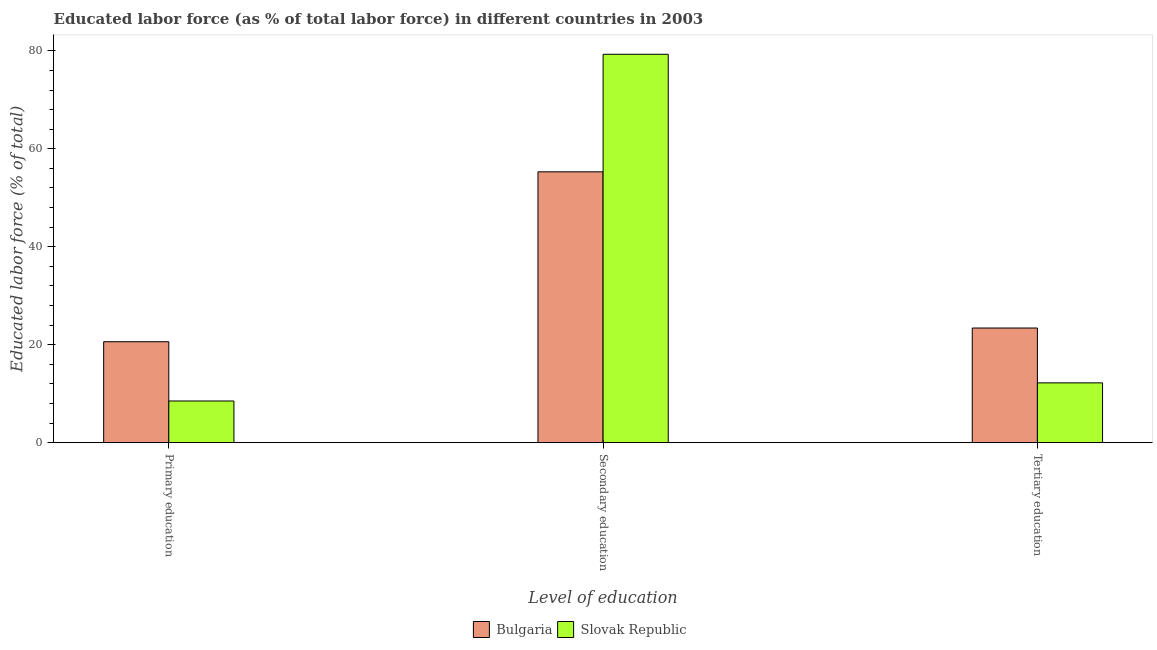How many different coloured bars are there?
Provide a short and direct response. 2. How many bars are there on the 1st tick from the right?
Ensure brevity in your answer.  2. What is the label of the 3rd group of bars from the left?
Make the answer very short. Tertiary education. What is the percentage of labor force who received tertiary education in Slovak Republic?
Provide a succinct answer. 12.2. Across all countries, what is the maximum percentage of labor force who received tertiary education?
Your response must be concise. 23.4. Across all countries, what is the minimum percentage of labor force who received tertiary education?
Keep it short and to the point. 12.2. In which country was the percentage of labor force who received secondary education maximum?
Your answer should be very brief. Slovak Republic. In which country was the percentage of labor force who received primary education minimum?
Offer a very short reply. Slovak Republic. What is the total percentage of labor force who received secondary education in the graph?
Provide a short and direct response. 134.6. What is the difference between the percentage of labor force who received tertiary education in Bulgaria and that in Slovak Republic?
Give a very brief answer. 11.2. What is the difference between the percentage of labor force who received tertiary education in Bulgaria and the percentage of labor force who received primary education in Slovak Republic?
Provide a succinct answer. 14.9. What is the average percentage of labor force who received secondary education per country?
Make the answer very short. 67.3. What is the difference between the percentage of labor force who received primary education and percentage of labor force who received tertiary education in Bulgaria?
Offer a terse response. -2.8. In how many countries, is the percentage of labor force who received primary education greater than 16 %?
Your answer should be compact. 1. What is the ratio of the percentage of labor force who received secondary education in Slovak Republic to that in Bulgaria?
Provide a short and direct response. 1.43. Is the percentage of labor force who received secondary education in Bulgaria less than that in Slovak Republic?
Your answer should be very brief. Yes. Is the difference between the percentage of labor force who received primary education in Slovak Republic and Bulgaria greater than the difference between the percentage of labor force who received tertiary education in Slovak Republic and Bulgaria?
Provide a short and direct response. No. What is the difference between the highest and the second highest percentage of labor force who received secondary education?
Your answer should be very brief. 24. What is the difference between the highest and the lowest percentage of labor force who received secondary education?
Provide a short and direct response. 24. What does the 1st bar from the left in Primary education represents?
Give a very brief answer. Bulgaria. What does the 1st bar from the right in Secondary education represents?
Give a very brief answer. Slovak Republic. How many bars are there?
Your response must be concise. 6. Are all the bars in the graph horizontal?
Give a very brief answer. No. How many countries are there in the graph?
Your response must be concise. 2. Are the values on the major ticks of Y-axis written in scientific E-notation?
Provide a short and direct response. No. Does the graph contain grids?
Your answer should be very brief. No. Where does the legend appear in the graph?
Give a very brief answer. Bottom center. How many legend labels are there?
Offer a very short reply. 2. What is the title of the graph?
Give a very brief answer. Educated labor force (as % of total labor force) in different countries in 2003. Does "Rwanda" appear as one of the legend labels in the graph?
Your answer should be very brief. No. What is the label or title of the X-axis?
Your answer should be compact. Level of education. What is the label or title of the Y-axis?
Your answer should be very brief. Educated labor force (% of total). What is the Educated labor force (% of total) in Bulgaria in Primary education?
Ensure brevity in your answer.  20.6. What is the Educated labor force (% of total) of Slovak Republic in Primary education?
Give a very brief answer. 8.5. What is the Educated labor force (% of total) in Bulgaria in Secondary education?
Provide a succinct answer. 55.3. What is the Educated labor force (% of total) of Slovak Republic in Secondary education?
Offer a terse response. 79.3. What is the Educated labor force (% of total) in Bulgaria in Tertiary education?
Keep it short and to the point. 23.4. What is the Educated labor force (% of total) in Slovak Republic in Tertiary education?
Ensure brevity in your answer.  12.2. Across all Level of education, what is the maximum Educated labor force (% of total) in Bulgaria?
Offer a terse response. 55.3. Across all Level of education, what is the maximum Educated labor force (% of total) in Slovak Republic?
Your answer should be very brief. 79.3. Across all Level of education, what is the minimum Educated labor force (% of total) of Bulgaria?
Your response must be concise. 20.6. What is the total Educated labor force (% of total) in Bulgaria in the graph?
Offer a very short reply. 99.3. What is the difference between the Educated labor force (% of total) in Bulgaria in Primary education and that in Secondary education?
Make the answer very short. -34.7. What is the difference between the Educated labor force (% of total) in Slovak Republic in Primary education and that in Secondary education?
Keep it short and to the point. -70.8. What is the difference between the Educated labor force (% of total) of Bulgaria in Primary education and that in Tertiary education?
Your response must be concise. -2.8. What is the difference between the Educated labor force (% of total) in Bulgaria in Secondary education and that in Tertiary education?
Offer a very short reply. 31.9. What is the difference between the Educated labor force (% of total) of Slovak Republic in Secondary education and that in Tertiary education?
Provide a succinct answer. 67.1. What is the difference between the Educated labor force (% of total) of Bulgaria in Primary education and the Educated labor force (% of total) of Slovak Republic in Secondary education?
Offer a terse response. -58.7. What is the difference between the Educated labor force (% of total) in Bulgaria in Secondary education and the Educated labor force (% of total) in Slovak Republic in Tertiary education?
Your answer should be very brief. 43.1. What is the average Educated labor force (% of total) in Bulgaria per Level of education?
Offer a very short reply. 33.1. What is the average Educated labor force (% of total) in Slovak Republic per Level of education?
Provide a succinct answer. 33.33. What is the difference between the Educated labor force (% of total) of Bulgaria and Educated labor force (% of total) of Slovak Republic in Tertiary education?
Offer a terse response. 11.2. What is the ratio of the Educated labor force (% of total) of Bulgaria in Primary education to that in Secondary education?
Make the answer very short. 0.37. What is the ratio of the Educated labor force (% of total) in Slovak Republic in Primary education to that in Secondary education?
Make the answer very short. 0.11. What is the ratio of the Educated labor force (% of total) of Bulgaria in Primary education to that in Tertiary education?
Make the answer very short. 0.88. What is the ratio of the Educated labor force (% of total) in Slovak Republic in Primary education to that in Tertiary education?
Your response must be concise. 0.7. What is the ratio of the Educated labor force (% of total) of Bulgaria in Secondary education to that in Tertiary education?
Keep it short and to the point. 2.36. What is the ratio of the Educated labor force (% of total) in Slovak Republic in Secondary education to that in Tertiary education?
Provide a succinct answer. 6.5. What is the difference between the highest and the second highest Educated labor force (% of total) of Bulgaria?
Keep it short and to the point. 31.9. What is the difference between the highest and the second highest Educated labor force (% of total) of Slovak Republic?
Make the answer very short. 67.1. What is the difference between the highest and the lowest Educated labor force (% of total) in Bulgaria?
Give a very brief answer. 34.7. What is the difference between the highest and the lowest Educated labor force (% of total) in Slovak Republic?
Your response must be concise. 70.8. 